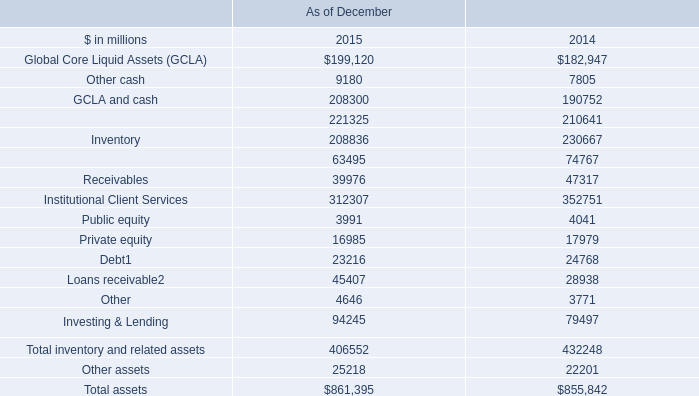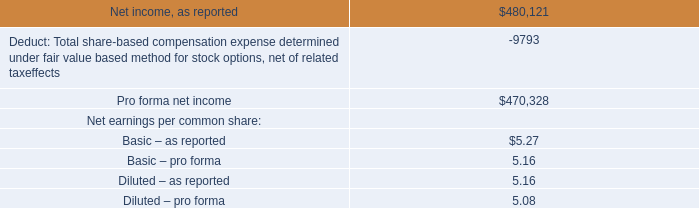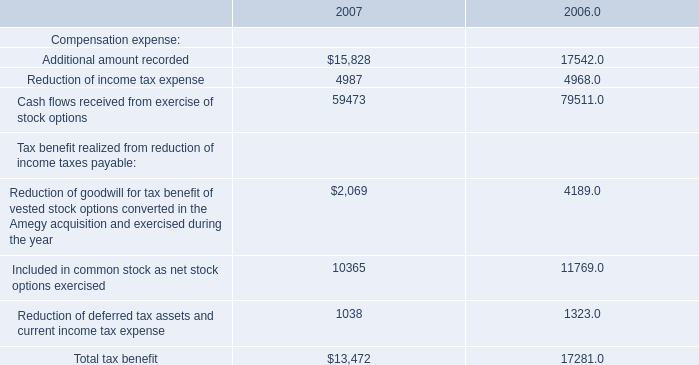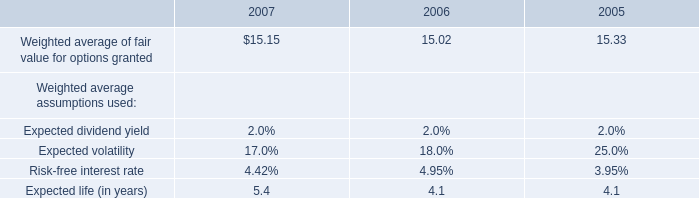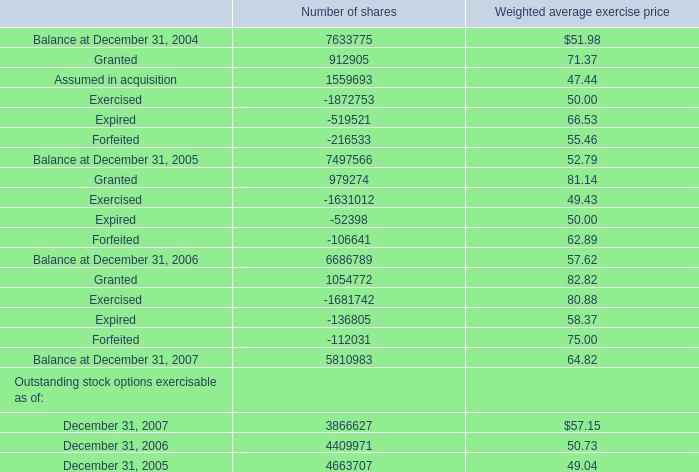What's the average of Granted of Number of shares, and Cash flows received from exercise of stock options of 2007 ? 
Computations: ((1054772.0 + 59473.0) / 2)
Answer: 557122.5. 